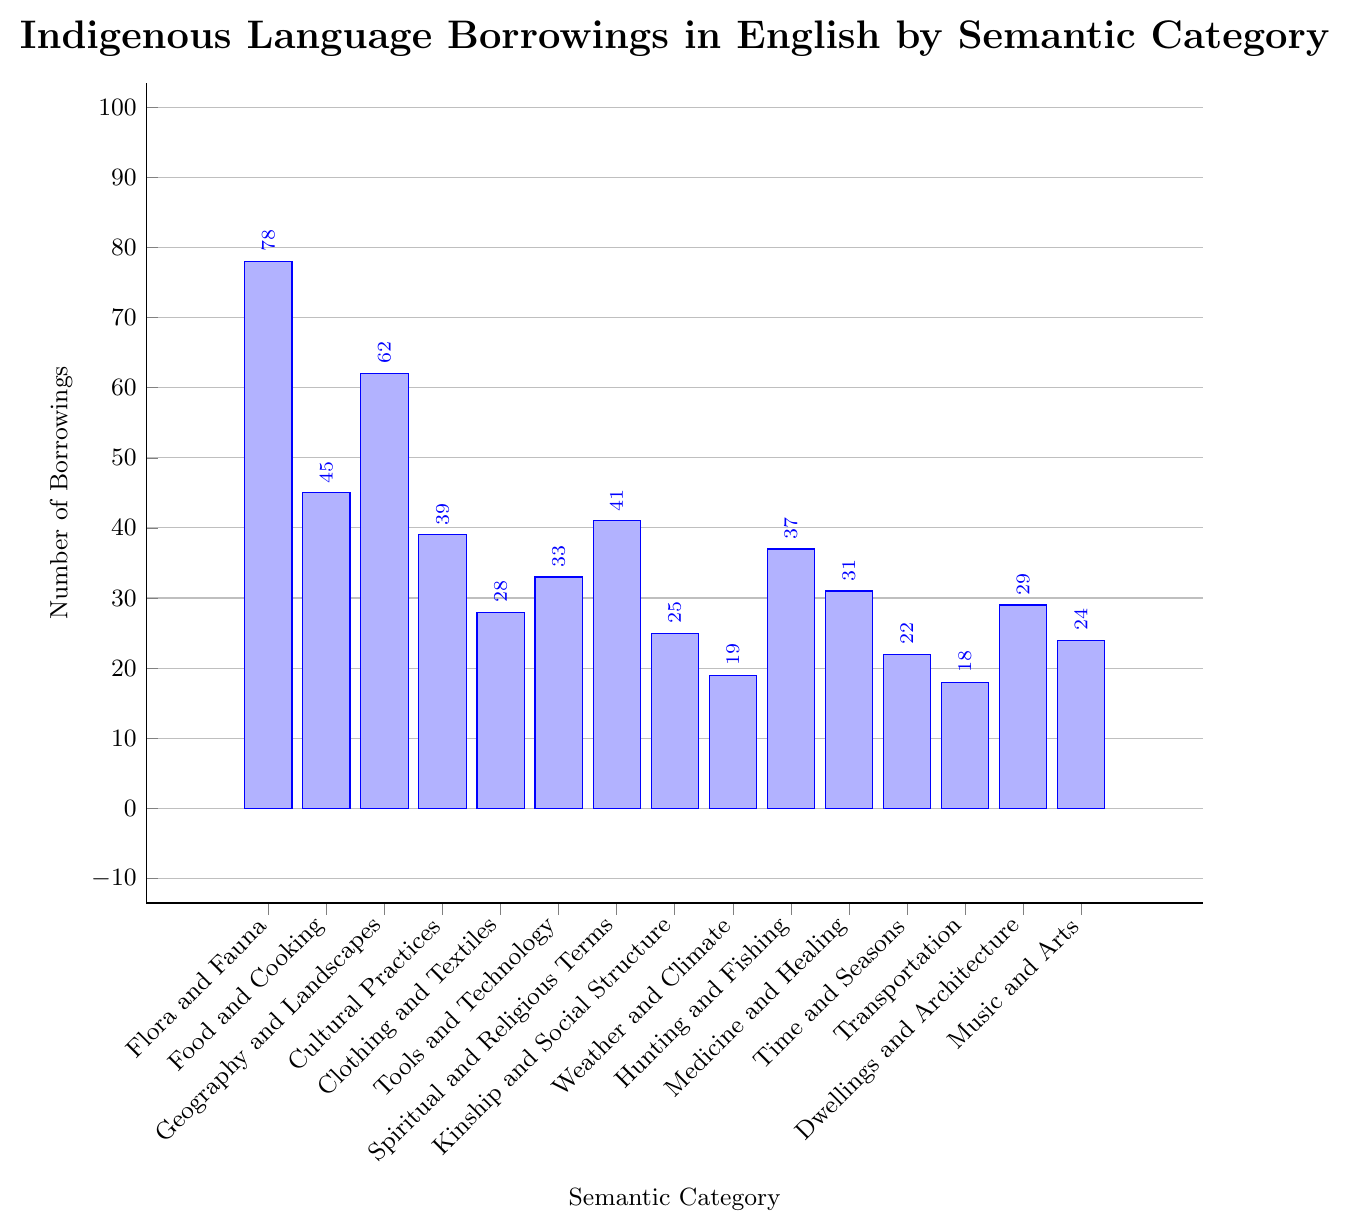Which category has the highest number of borrowings? In the chart, the tallest bar represents the category with the highest number of borrowings. The bar for "Flora and Fauna" is the tallest.
Answer: Flora and Fauna What is the difference in the number of borrowings between "Flora and Fauna" and "Spiritual and Religious Terms"? To find the difference, subtract the number of borrowings in "Spiritual and Religious Terms" from the number in "Flora and Fauna": 78 - 41 = 37.
Answer: 37 Which category has fewer borrowings: "Clothing and Textiles" or "Tools and Technology"? By comparing the heights of the bars, "Clothing and Textiles" has fewer borrowings (28) than "Tools and Technology" (33).
Answer: Clothing and Textiles What is the average number of borrowings among "Geography and Landscapes", "Cultural Practices", and "Food and Cooking"? Sum the borrowings in these categories and divide by three: (62 + 39 + 45) / 3. The calculation is 146 / 3 = approximately 48.67.
Answer: approximately 48.67 Which categories have fewer than 30 borrowings? Identify and list the categories with bar heights corresponding to fewer than 30 borrowings: "Clothing and Textiles" (28), "Kinship and Social Structure" (25), "Weather and Climate" (19), "Time and Seasons" (22), "Transportation" (18), "Music and Arts" (24).
Answer: Clothing and Textiles, Kinship and Social Structure, Weather and Climate, Time and Seasons, Transportation, Music and Arts How many more borrowings does "Hunting and Fishing" have compared to "Medicine and Healing"? Subtract the number of borrowings in "Medicine and Healing" from "Hunting and Fishing": 37 - 31 = 6.
Answer: 6 What is the sum of borrowings in "Medicine and Healing", "Time and Seasons", and "Dwellings and Architecture"? Add the number of borrowings in each category: 31 + 22 + 29 = 82.
Answer: 82 Are there more borrowings in "Food and Cooking" or "Hunting and Fishing"? Compare the bar heights: "Food and Cooking" has 45 borrowings, and "Hunting and Fishing" has 37 borrowings.
Answer: Food and Cooking Which category has a bar with a height of fewer than 20 borrowings? Find the category with a bar height that indicates fewer than 20 borrowings: "Weather and Climate" (19) and "Transportation" (18).
Answer: Weather and Climate, Transportation 